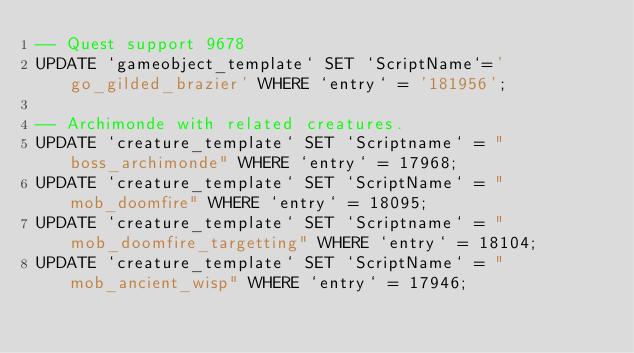<code> <loc_0><loc_0><loc_500><loc_500><_SQL_>-- Quest support 9678
UPDATE `gameobject_template` SET `ScriptName`='go_gilded_brazier' WHERE `entry` = '181956';

-- Archimonde with related creatures.
UPDATE `creature_template` SET `Scriptname` = "boss_archimonde" WHERE `entry` = 17968;
UPDATE `creature_template` SET `ScriptName` = "mob_doomfire" WHERE `entry` = 18095;
UPDATE `creature_template` SET `Scriptname` = "mob_doomfire_targetting" WHERE `entry` = 18104;
UPDATE `creature_template` SET `ScriptName` = "mob_ancient_wisp" WHERE `entry` = 17946;
</code> 